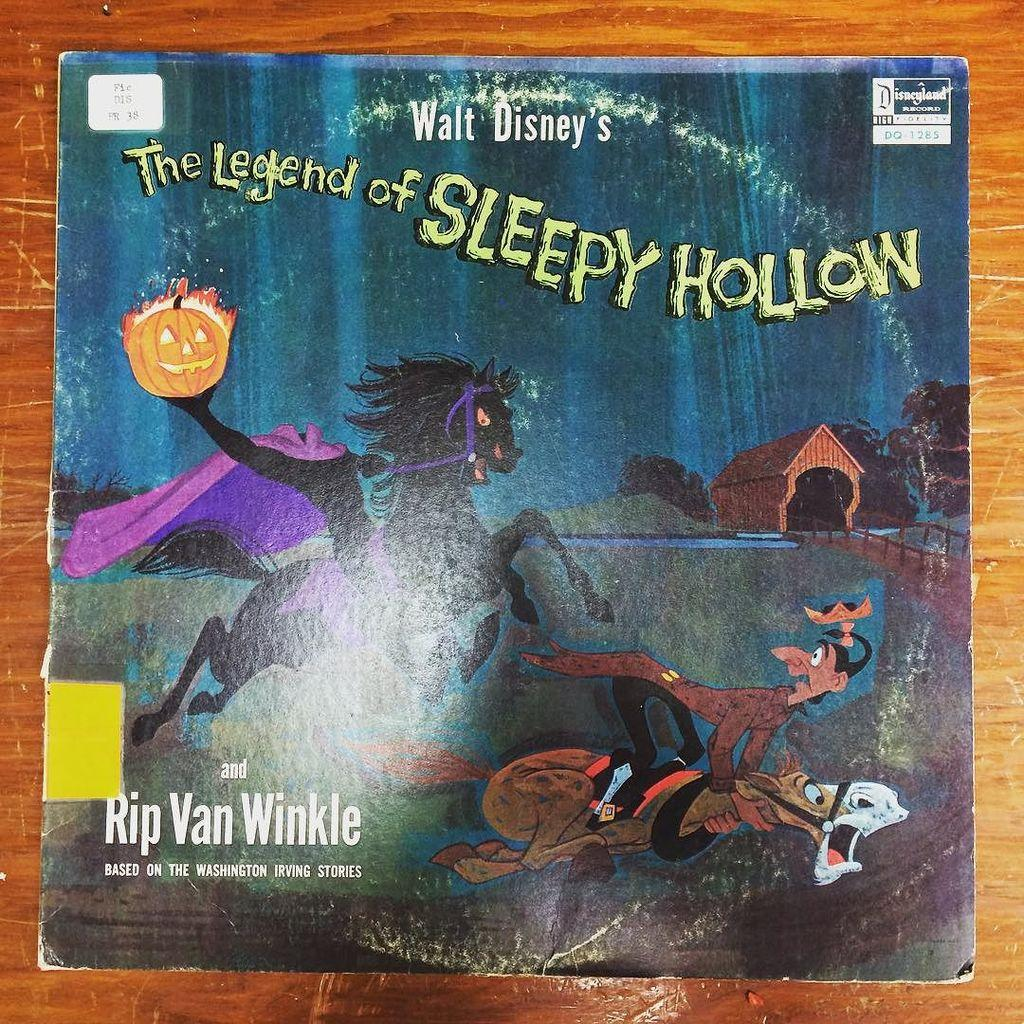What type of poster is in the image? There is a cartoon poster in the image. What characters are featured on the poster? The poster features a witch, a horse, and a man. What is the poster placed on? The poster is on a card. Where is the card located? The card is on a wooden table. Where is the nest of the bird that is not present in the image? There is no bird or nest present in the image, so it is not possible to determine the location of a nest. 